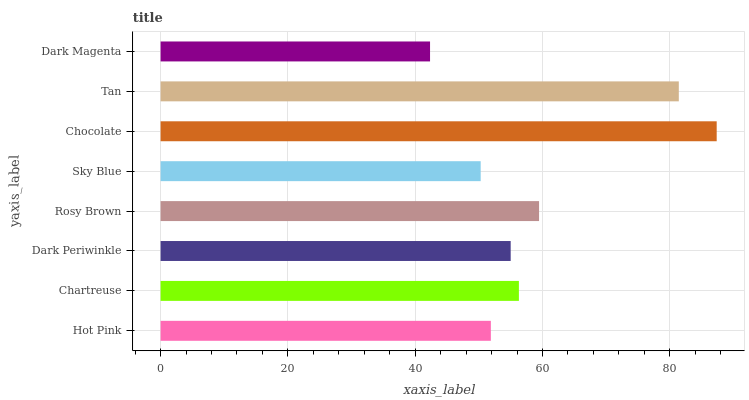Is Dark Magenta the minimum?
Answer yes or no. Yes. Is Chocolate the maximum?
Answer yes or no. Yes. Is Chartreuse the minimum?
Answer yes or no. No. Is Chartreuse the maximum?
Answer yes or no. No. Is Chartreuse greater than Hot Pink?
Answer yes or no. Yes. Is Hot Pink less than Chartreuse?
Answer yes or no. Yes. Is Hot Pink greater than Chartreuse?
Answer yes or no. No. Is Chartreuse less than Hot Pink?
Answer yes or no. No. Is Chartreuse the high median?
Answer yes or no. Yes. Is Dark Periwinkle the low median?
Answer yes or no. Yes. Is Tan the high median?
Answer yes or no. No. Is Chartreuse the low median?
Answer yes or no. No. 